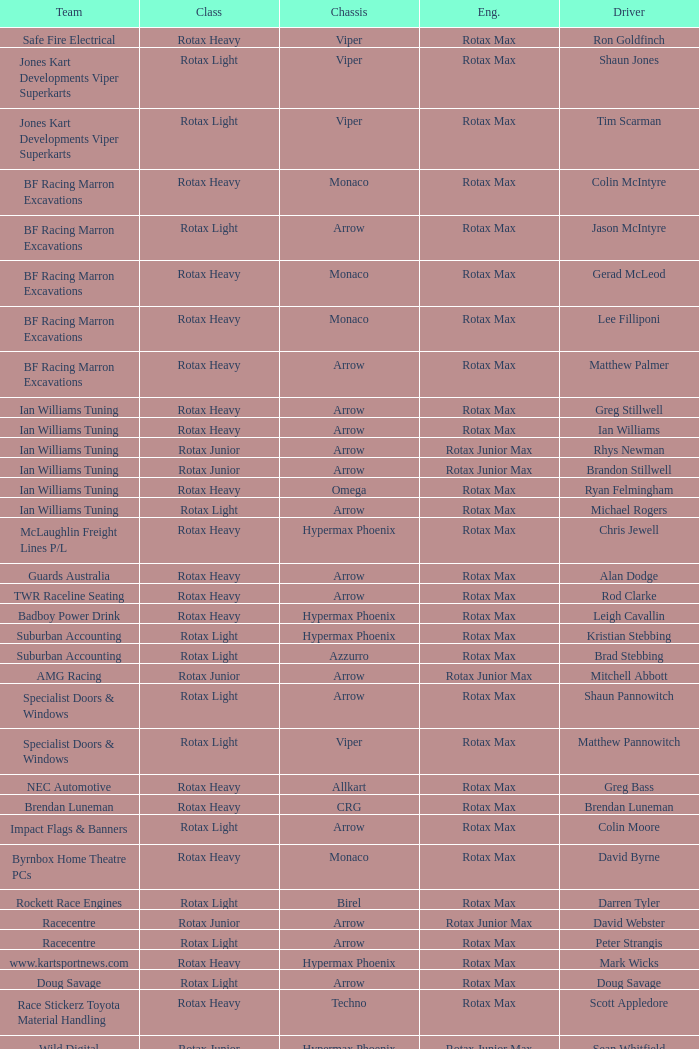What is the name of the team whose class is Rotax Light? Jones Kart Developments Viper Superkarts, Jones Kart Developments Viper Superkarts, BF Racing Marron Excavations, Ian Williams Tuning, Suburban Accounting, Suburban Accounting, Specialist Doors & Windows, Specialist Doors & Windows, Impact Flags & Banners, Rockett Race Engines, Racecentre, Doug Savage. 